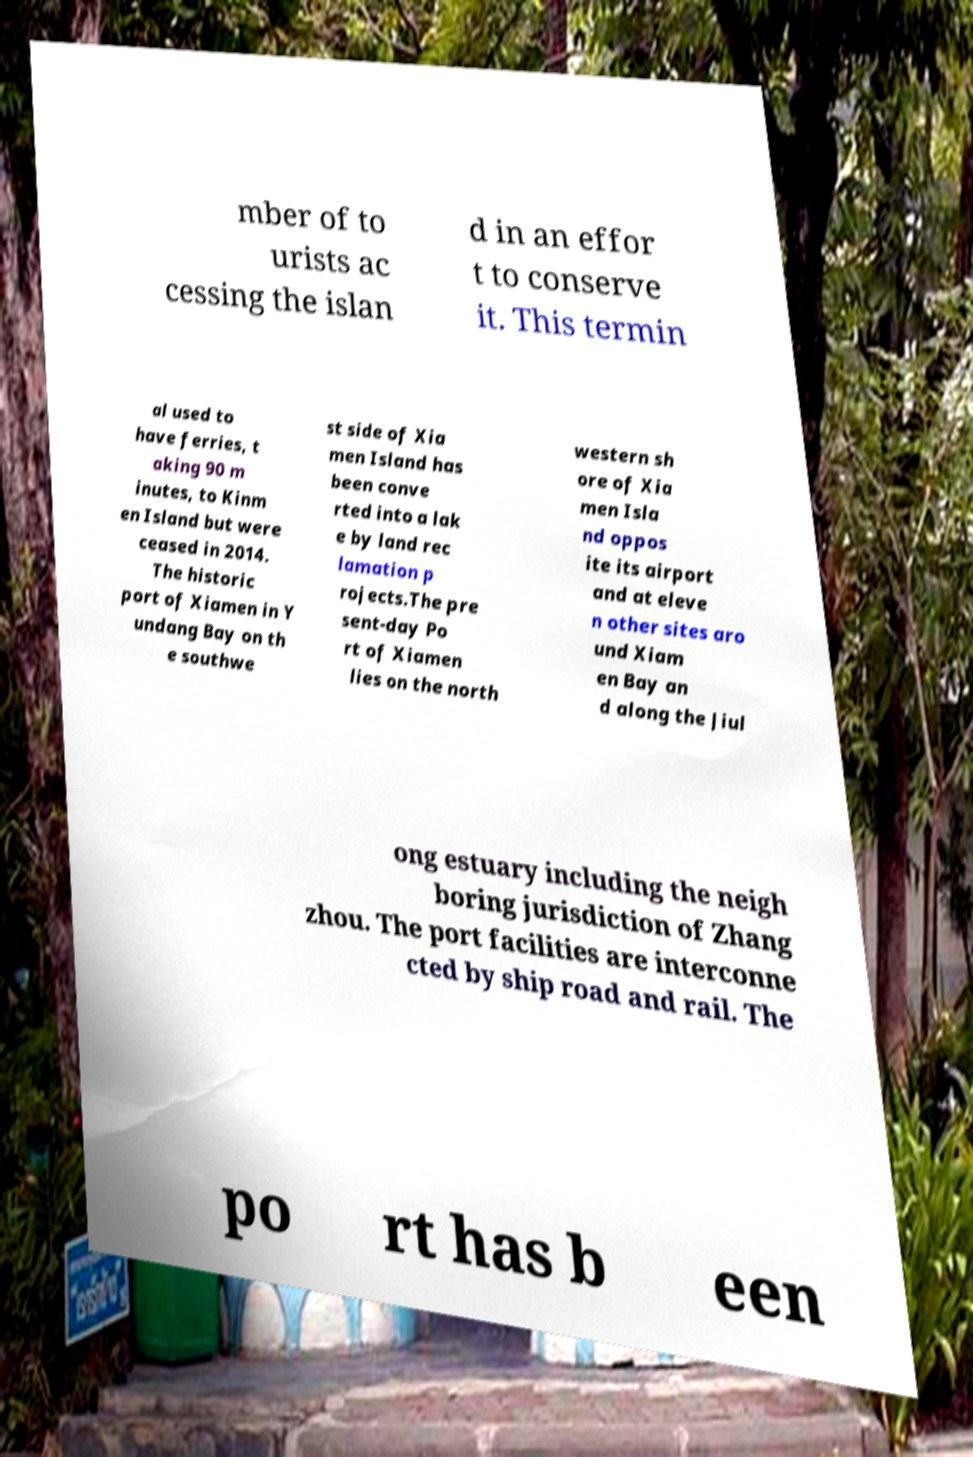For documentation purposes, I need the text within this image transcribed. Could you provide that? mber of to urists ac cessing the islan d in an effor t to conserve it. This termin al used to have ferries, t aking 90 m inutes, to Kinm en Island but were ceased in 2014. The historic port of Xiamen in Y undang Bay on th e southwe st side of Xia men Island has been conve rted into a lak e by land rec lamation p rojects.The pre sent-day Po rt of Xiamen lies on the north western sh ore of Xia men Isla nd oppos ite its airport and at eleve n other sites aro und Xiam en Bay an d along the Jiul ong estuary including the neigh boring jurisdiction of Zhang zhou. The port facilities are interconne cted by ship road and rail. The po rt has b een 